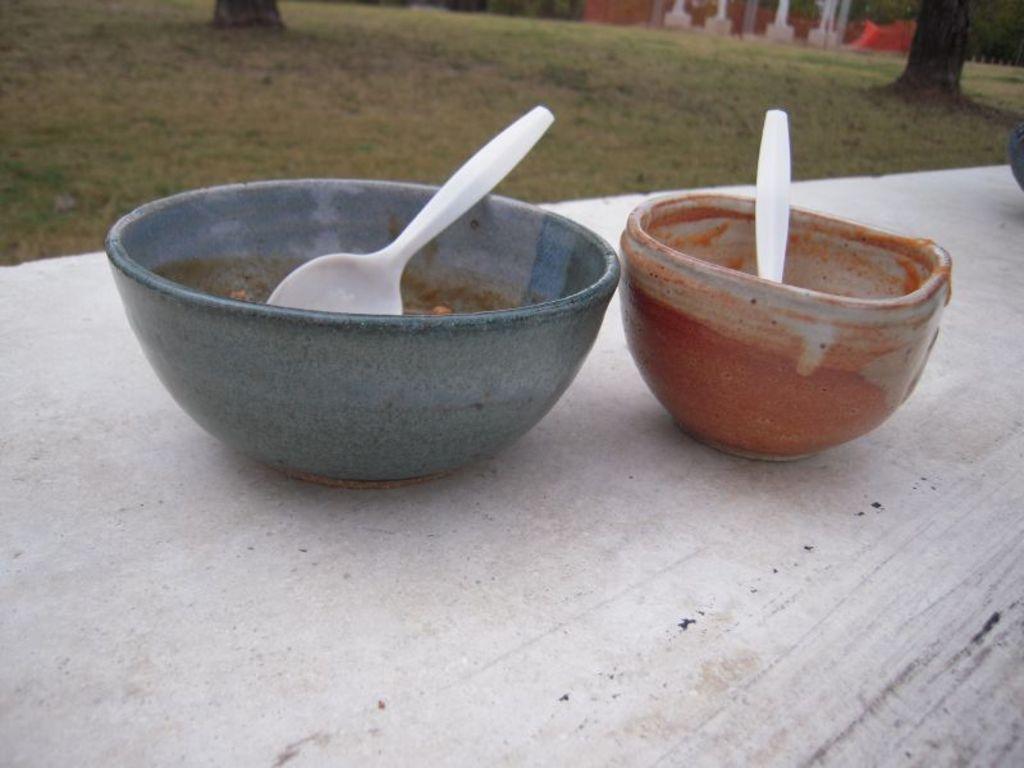Describe this image in one or two sentences. There are two bowls in which there are spoons in the foreground, there are trees, grassland, it seems like a house in the background area. 